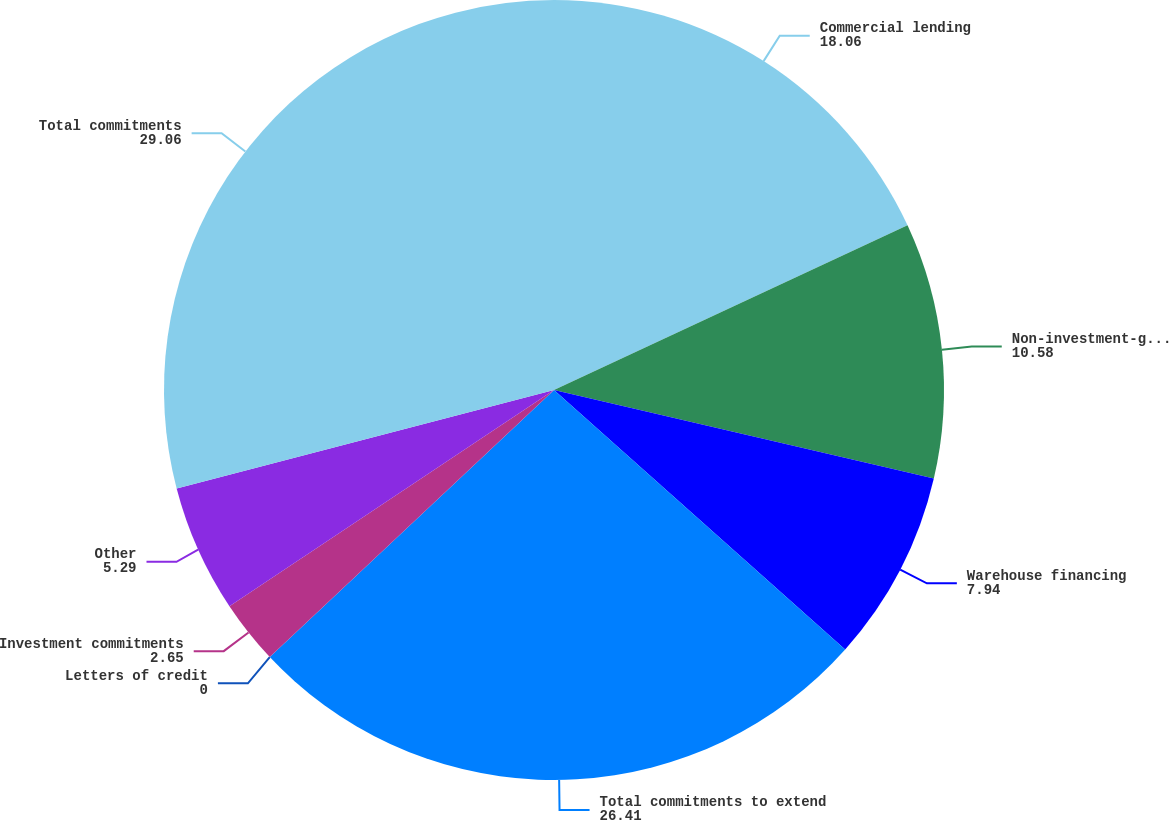Convert chart to OTSL. <chart><loc_0><loc_0><loc_500><loc_500><pie_chart><fcel>Commercial lending<fcel>Non-investment-grade<fcel>Warehouse financing<fcel>Total commitments to extend<fcel>Letters of credit<fcel>Investment commitments<fcel>Other<fcel>Total commitments<nl><fcel>18.06%<fcel>10.58%<fcel>7.94%<fcel>26.41%<fcel>0.0%<fcel>2.65%<fcel>5.29%<fcel>29.06%<nl></chart> 